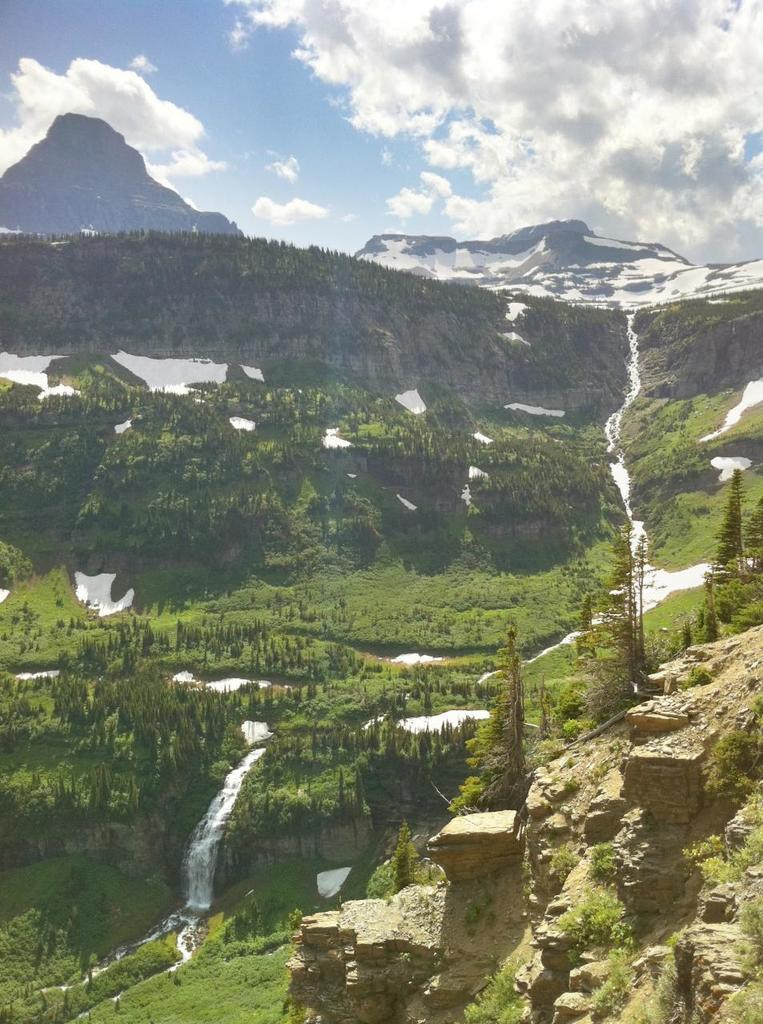What can be found at the bottom of the image? At the bottom of the image, there are stones, trees, a waterfall, water, and grass. What is visible at the top of the image? At the top of the image, there are hills, trees, ice, grass, and the sky. What is the condition of the sky in the image? The sky is visible at the top of the image, and there are clouds in the sky. How many pies are being held by the trees at the top of the image? There are no pies present in the image; the trees are not holding any pies. What type of riddle can be solved by looking at the thumb in the image? There is no thumb present in the image, so it cannot be used to solve any riddles. 